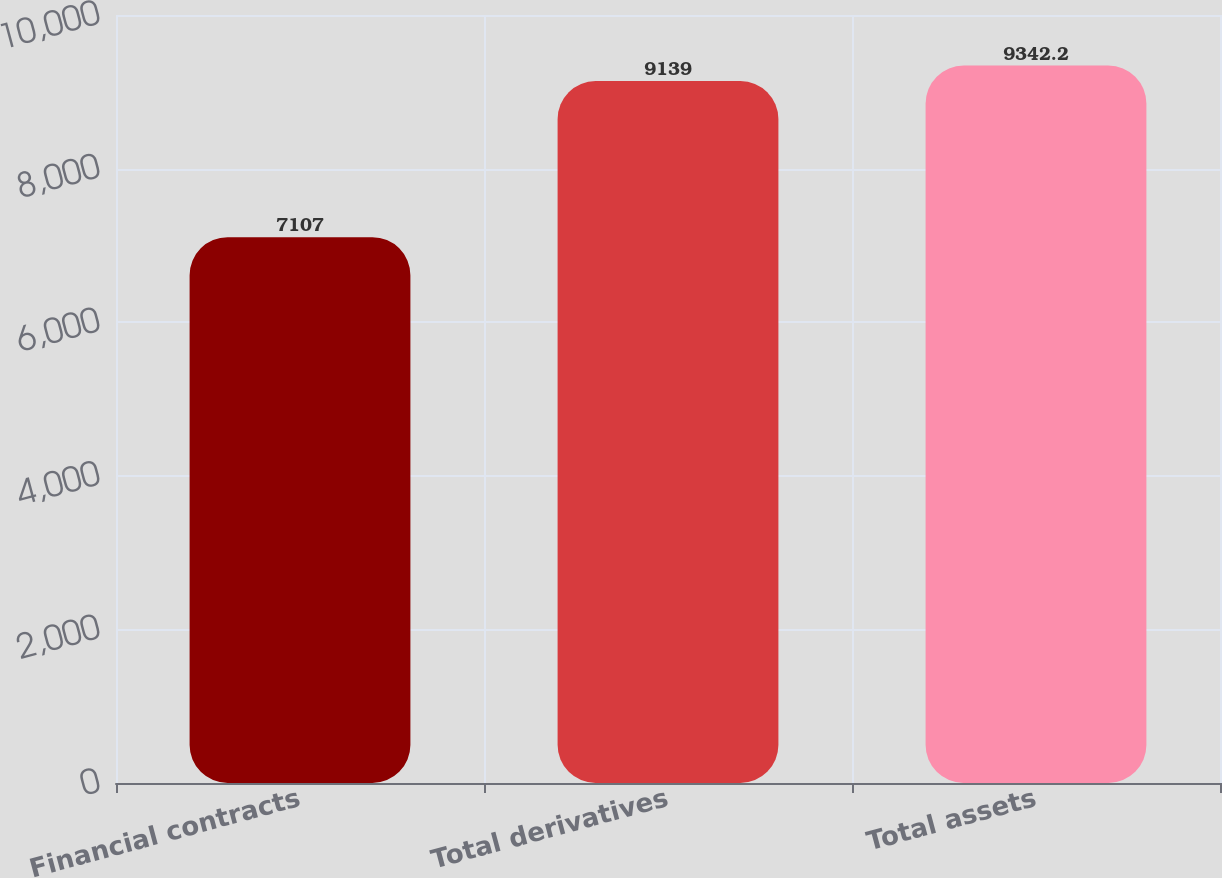Convert chart to OTSL. <chart><loc_0><loc_0><loc_500><loc_500><bar_chart><fcel>Financial contracts<fcel>Total derivatives<fcel>Total assets<nl><fcel>7107<fcel>9139<fcel>9342.2<nl></chart> 